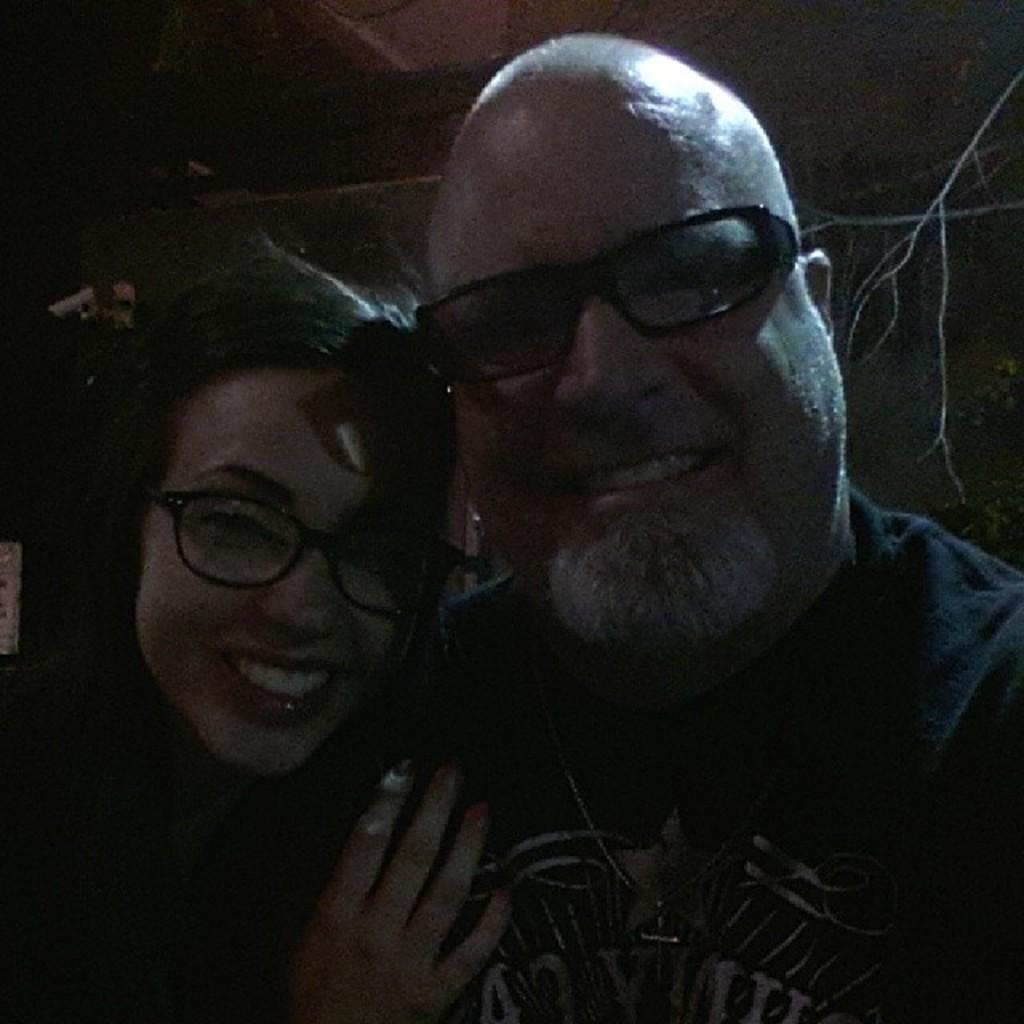What can be inferred about the lighting conditions in the image? The image was taken in a dark environment. Who is present in the image? There is a man and a woman in the image. What expressions do the man and woman have in the image? The man and woman are both smiling in the image. What are the man and woman doing in the image? The man and woman are posing for the picture. What type of pencil can be seen in the hands of the man in the image? There is no pencil present in the image; the man and woman are not holding any objects. Can you tell me how many kitties are sitting on the woman's lap in the image? There are no kitties present in the image; the man and woman are the only subjects. 